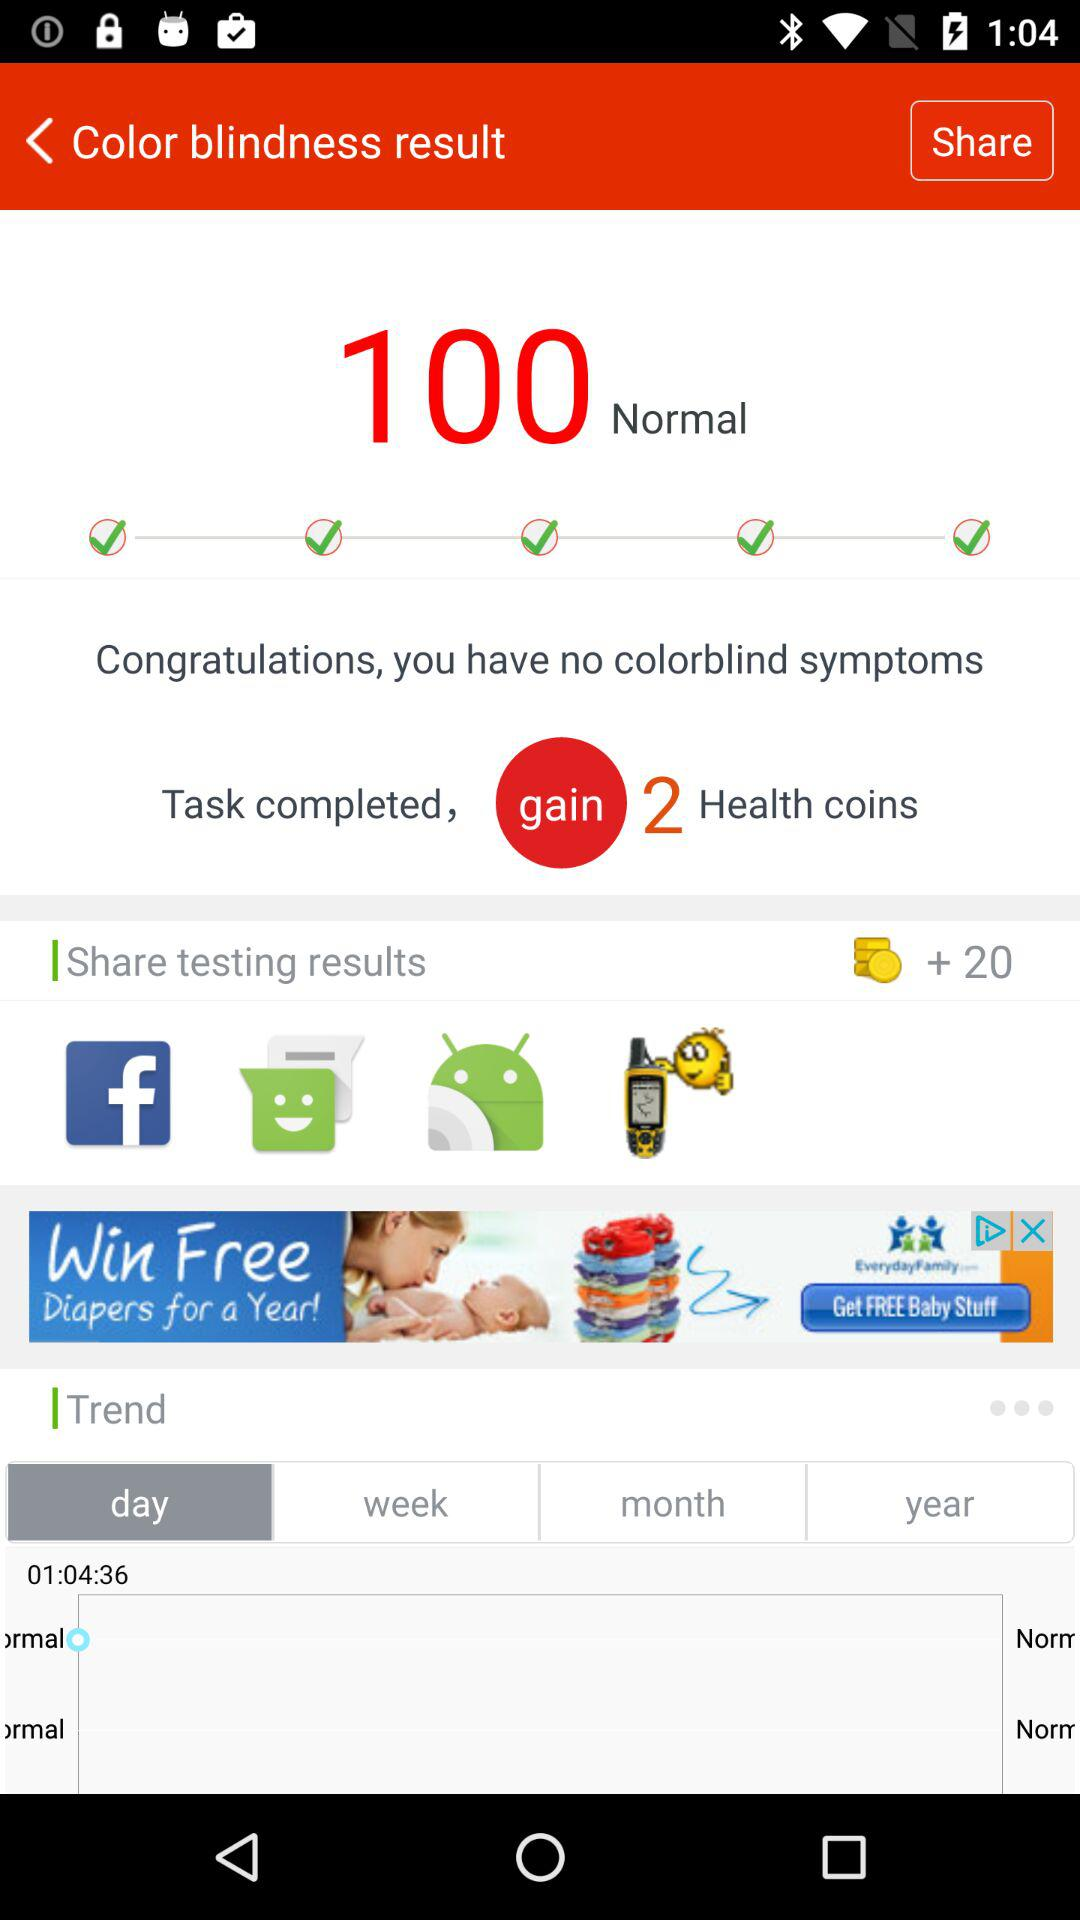How many health coins do I have?
Answer the question using a single word or phrase. 2 